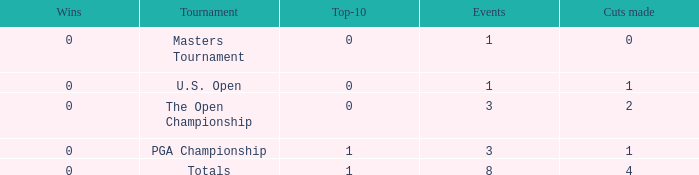For more than 3 events in the PGA Championship, what is the fewest number of wins? None. 